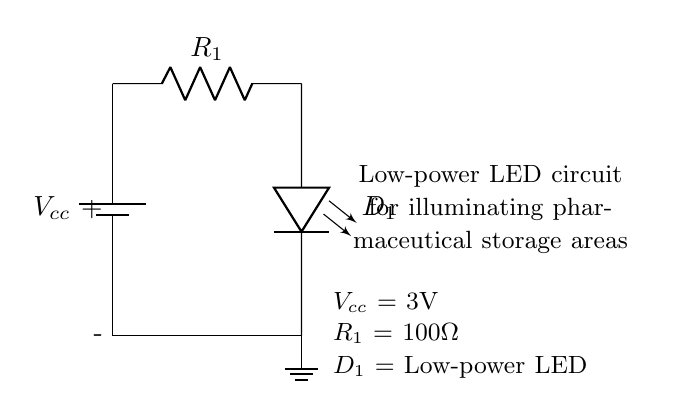What is the value of the power supply voltage? The power supply voltage is indicated as Vcc. From the circuit diagram, it is labeled as 3V.
Answer: 3V What type of LED is used in this circuit? The circuit diagram specifies the LED as a low-power LED, labeling it as D1. This indicates it is designed for low power consumption.
Answer: Low-power LED What is the value of the current limiting resistor? The circuit diagram shows the component R1, which is labeled with a value of 100 ohms. This is the resistor that limits the current flowing through the LED.
Answer: 100 ohms What is the total number of components in the circuit? The circuit consists of three components: one battery, one resistor, and one LED. Counting these gives a total of three components.
Answer: Three Why is a current limiting resistor used in this circuit? The current limiting resistor (R1) is utilized to prevent excessive current from flowing through the LED, which can damage it. The resistor ensures that the LED operates within its safe current range, enhancing its longevity.
Answer: To limit current Which component is located at the bottom of the circuit? The circuit diagram indicates that the ground is positioned at the bottom and is connected to the LED, which is the last component before ground.
Answer: Ground What would happen if R1 was omitted from the circuit? If R1 were omitted, the current flowing through the LED would exceed its maximum rated value, likely leading to immediate failure of the LED due to overheating or damage. The resistor is critical for maintaining appropriate current levels.
Answer: LED may fail 